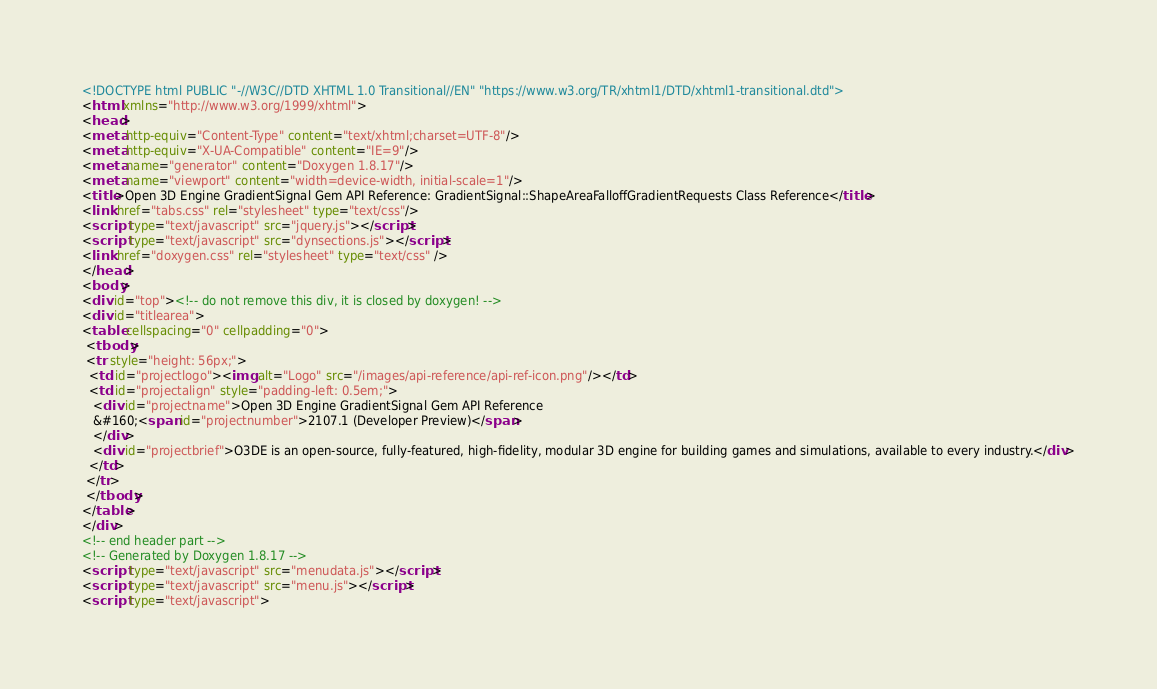<code> <loc_0><loc_0><loc_500><loc_500><_HTML_><!DOCTYPE html PUBLIC "-//W3C//DTD XHTML 1.0 Transitional//EN" "https://www.w3.org/TR/xhtml1/DTD/xhtml1-transitional.dtd">
<html xmlns="http://www.w3.org/1999/xhtml">
<head>
<meta http-equiv="Content-Type" content="text/xhtml;charset=UTF-8"/>
<meta http-equiv="X-UA-Compatible" content="IE=9"/>
<meta name="generator" content="Doxygen 1.8.17"/>
<meta name="viewport" content="width=device-width, initial-scale=1"/>
<title>Open 3D Engine GradientSignal Gem API Reference: GradientSignal::ShapeAreaFalloffGradientRequests Class Reference</title>
<link href="tabs.css" rel="stylesheet" type="text/css"/>
<script type="text/javascript" src="jquery.js"></script>
<script type="text/javascript" src="dynsections.js"></script>
<link href="doxygen.css" rel="stylesheet" type="text/css" />
</head>
<body>
<div id="top"><!-- do not remove this div, it is closed by doxygen! -->
<div id="titlearea">
<table cellspacing="0" cellpadding="0">
 <tbody>
 <tr style="height: 56px;">
  <td id="projectlogo"><img alt="Logo" src="/images/api-reference/api-ref-icon.png"/></td>
  <td id="projectalign" style="padding-left: 0.5em;">
   <div id="projectname">Open 3D Engine GradientSignal Gem API Reference
   &#160;<span id="projectnumber">2107.1 (Developer Preview)</span>
   </div>
   <div id="projectbrief">O3DE is an open-source, fully-featured, high-fidelity, modular 3D engine for building games and simulations, available to every industry.</div>
  </td>
 </tr>
 </tbody>
</table>
</div>
<!-- end header part -->
<!-- Generated by Doxygen 1.8.17 -->
<script type="text/javascript" src="menudata.js"></script>
<script type="text/javascript" src="menu.js"></script>
<script type="text/javascript"></code> 